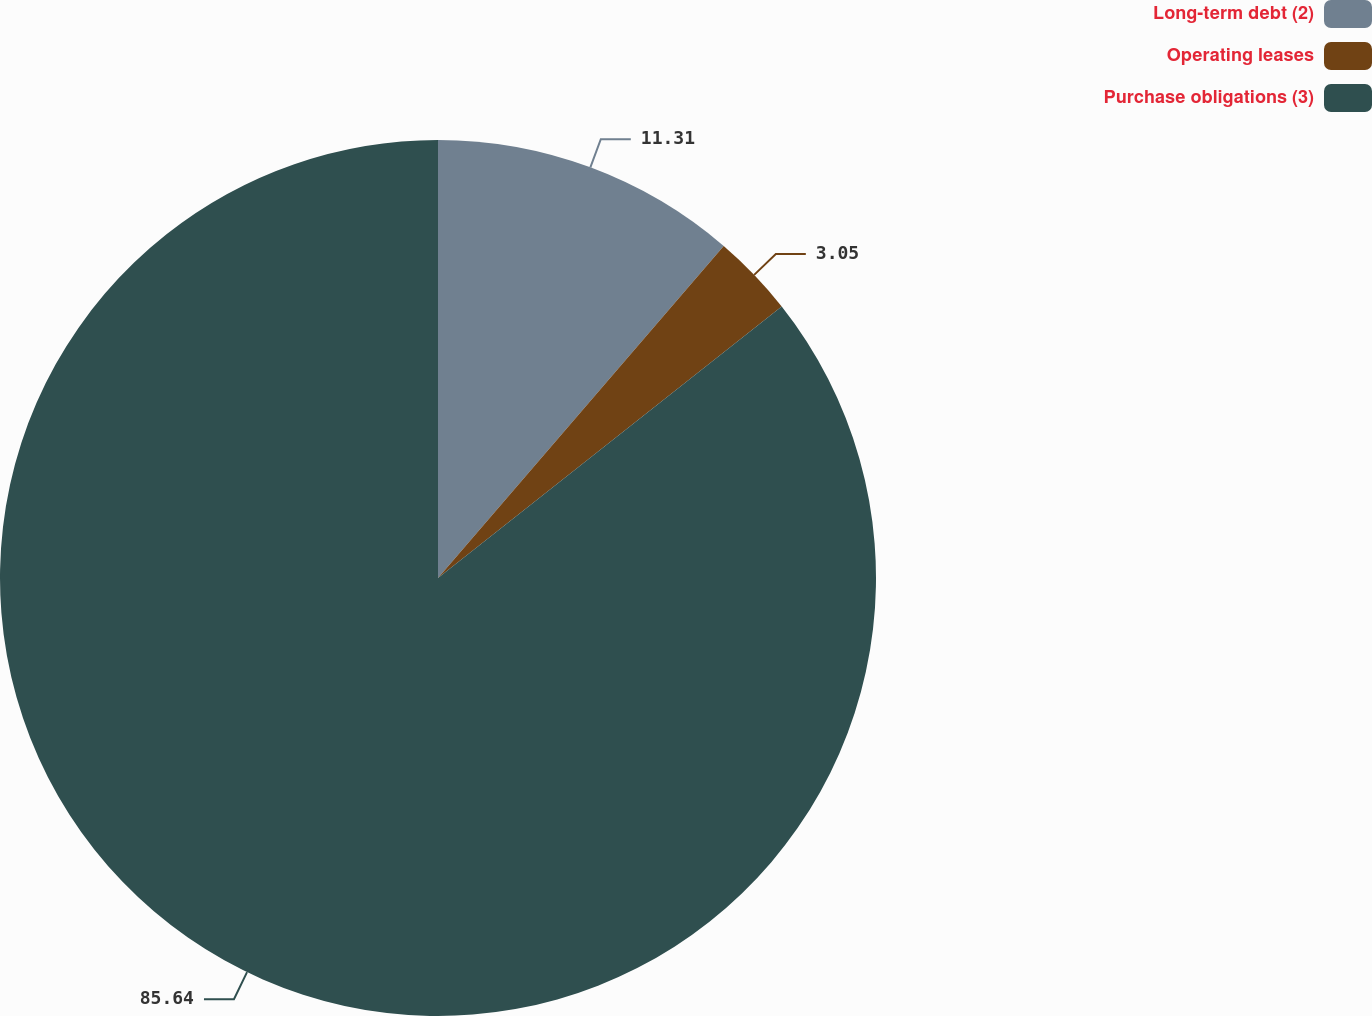<chart> <loc_0><loc_0><loc_500><loc_500><pie_chart><fcel>Long-term debt (2)<fcel>Operating leases<fcel>Purchase obligations (3)<nl><fcel>11.31%<fcel>3.05%<fcel>85.64%<nl></chart> 